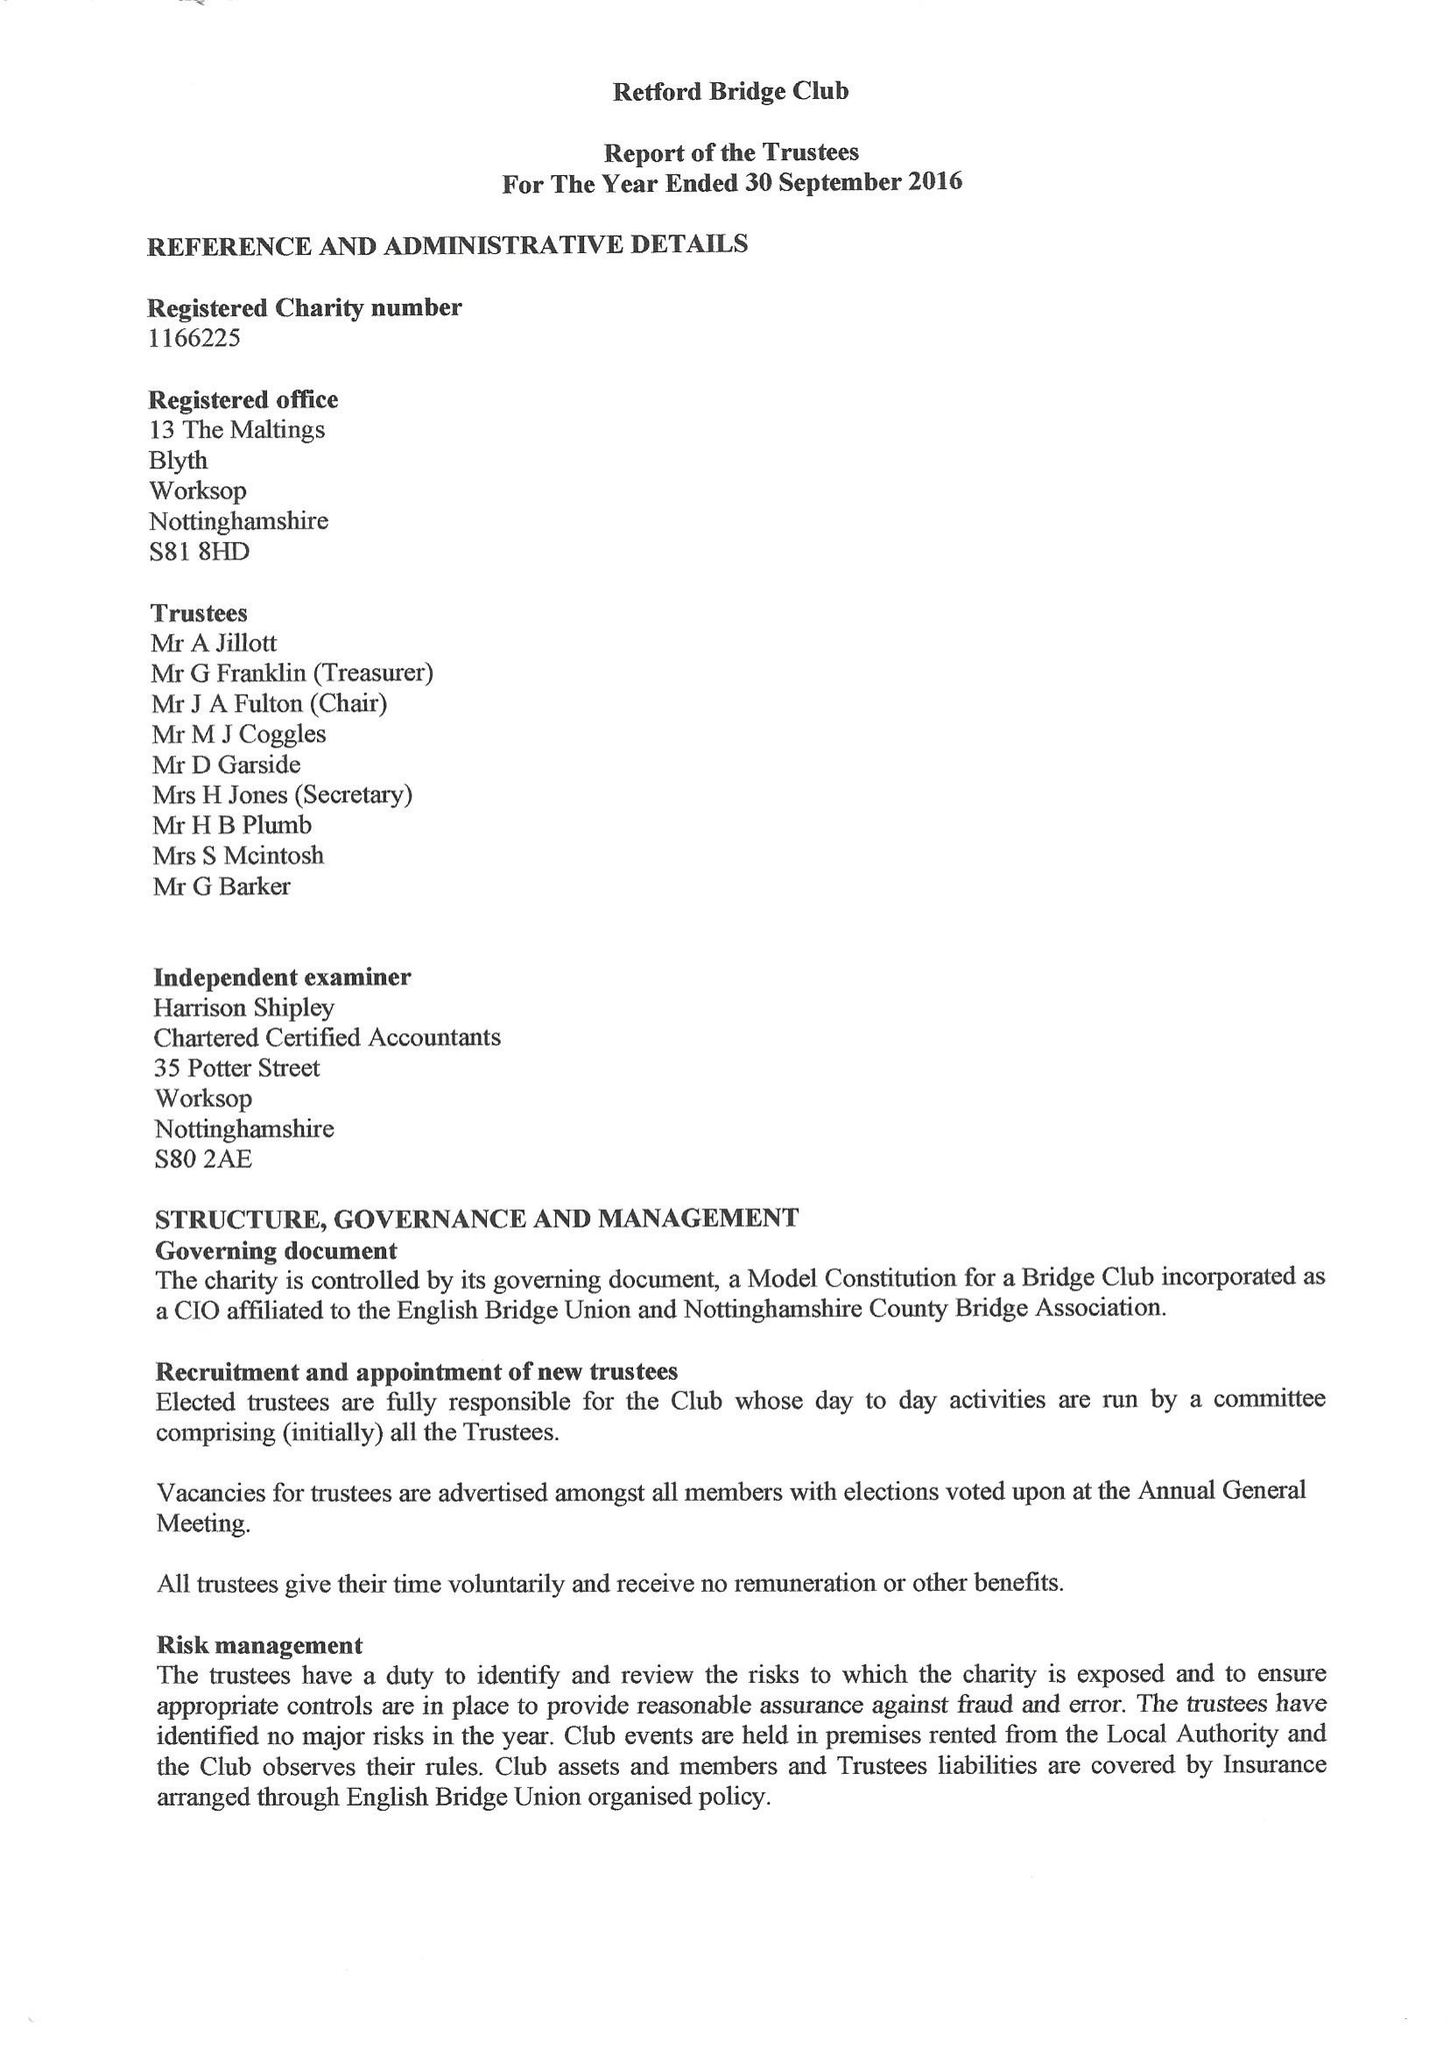What is the value for the address__post_town?
Answer the question using a single word or phrase. WORKSOP 